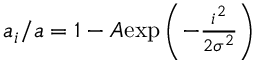<formula> <loc_0><loc_0><loc_500><loc_500>\begin{array} { r } { a _ { i } / a = 1 - A e x p \left ( { - \frac { i ^ { 2 } } { 2 \sigma ^ { 2 } } } \right ) } \end{array}</formula> 